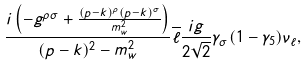Convert formula to latex. <formula><loc_0><loc_0><loc_500><loc_500>\frac { i \left ( - g ^ { { \rho } { \sigma } } + \frac { ( p - k ) ^ { \rho } ( p - k ) ^ { \sigma } } { m _ { w } ^ { 2 } } \right ) } { ( p - k ) ^ { 2 } - m _ { w } ^ { 2 } } \overline { \ell } \frac { i g } { 2 \sqrt { 2 } } \gamma _ { \sigma } ( 1 - { \gamma } _ { 5 } ) \nu _ { \ell } ,</formula> 